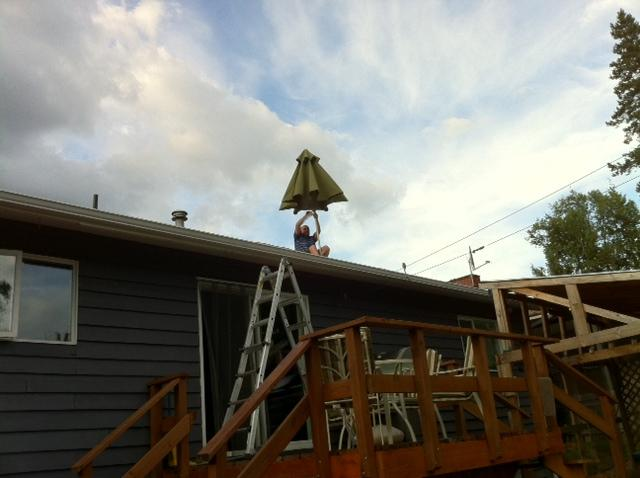What does the item the man is holding provide? Please explain your reasoning. shade. The item is shade. 